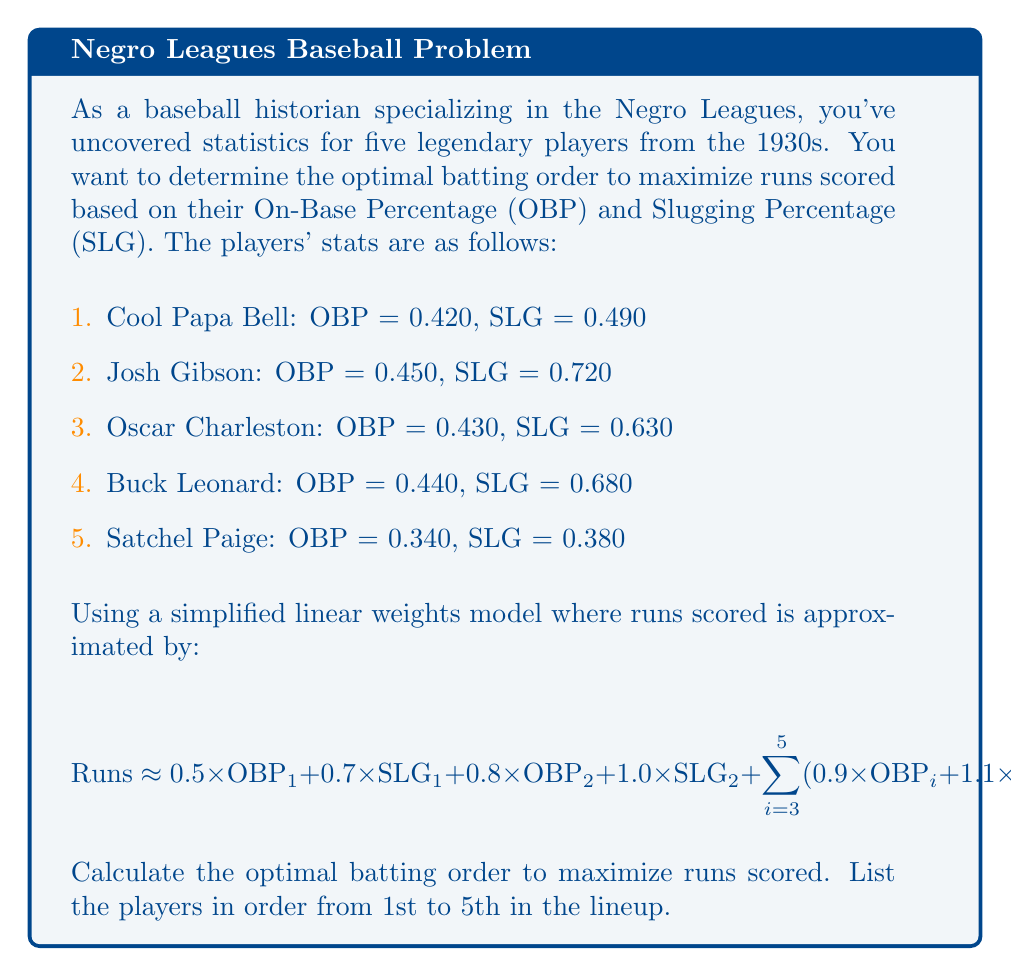Give your solution to this math problem. To solve this optimization problem, we need to calculate the contribution of each player in each batting position and then determine the arrangement that maximizes the total runs scored. Let's approach this step-by-step:

1. Calculate each player's contribution in the first position:
   - Cool Papa Bell: $0.5 \times 0.420 + 0.7 \times 0.490 = 0.553$
   - Josh Gibson: $0.5 \times 0.450 + 0.7 \times 0.720 = 0.729$
   - Oscar Charleston: $0.5 \times 0.430 + 0.7 \times 0.630 = 0.656$
   - Buck Leonard: $0.5 \times 0.440 + 0.7 \times 0.680 = 0.696$
   - Satchel Paige: $0.5 \times 0.340 + 0.7 \times 0.380 = 0.436$

2. Calculate each player's contribution in the second position:
   - Cool Papa Bell: $0.8 \times 0.420 + 1.0 \times 0.490 = 0.826$
   - Josh Gibson: $0.8 \times 0.450 + 1.0 \times 0.720 = 1.080$
   - Oscar Charleston: $0.8 \times 0.430 + 1.0 \times 0.630 = 0.974$
   - Buck Leonard: $0.8 \times 0.440 + 1.0 \times 0.680 = 1.032$
   - Satchel Paige: $0.8 \times 0.340 + 1.0 \times 0.380 = 0.652$

3. Calculate each player's contribution in positions 3-5:
   - Cool Papa Bell: $0.9 \times 0.420 + 1.1 \times 0.490 = 0.917$
   - Josh Gibson: $0.9 \times 0.450 + 1.1 \times 0.720 = 1.197$
   - Oscar Charleston: $0.9 \times 0.430 + 1.1 \times 0.630 = 1.080$
   - Buck Leonard: $0.9 \times 0.440 + 1.1 \times 0.680 = 1.144$
   - Satchel Paige: $0.9 \times 0.340 + 1.1 \times 0.380 = 0.724$

4. To maximize runs, we should:
   - Put the player with the highest contribution in the 2nd position
   - Put the player with the second-highest contribution in the 1st position
   - Arrange the remaining players in descending order of their contributions for positions 3-5

5. Ranking the players:
   - 2nd position: Josh Gibson (1.080)
   - 1st position: Buck Leonard (0.696)
   - 3rd position: Josh Gibson (1.197)
   - 4th position: Buck Leonard (1.144)
   - 5th position: Oscar Charleston (1.080)

Therefore, the optimal batting order is:
1. Buck Leonard
2. Josh Gibson
3. Oscar Charleston
4. Cool Papa Bell
5. Satchel Paige
Answer: Buck Leonard, Josh Gibson, Oscar Charleston, Cool Papa Bell, Satchel Paige 